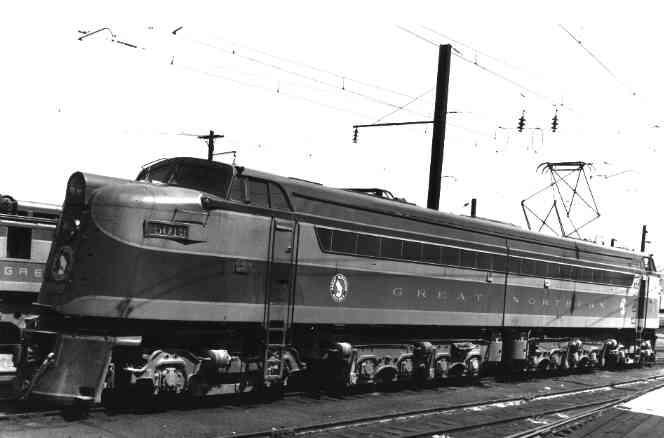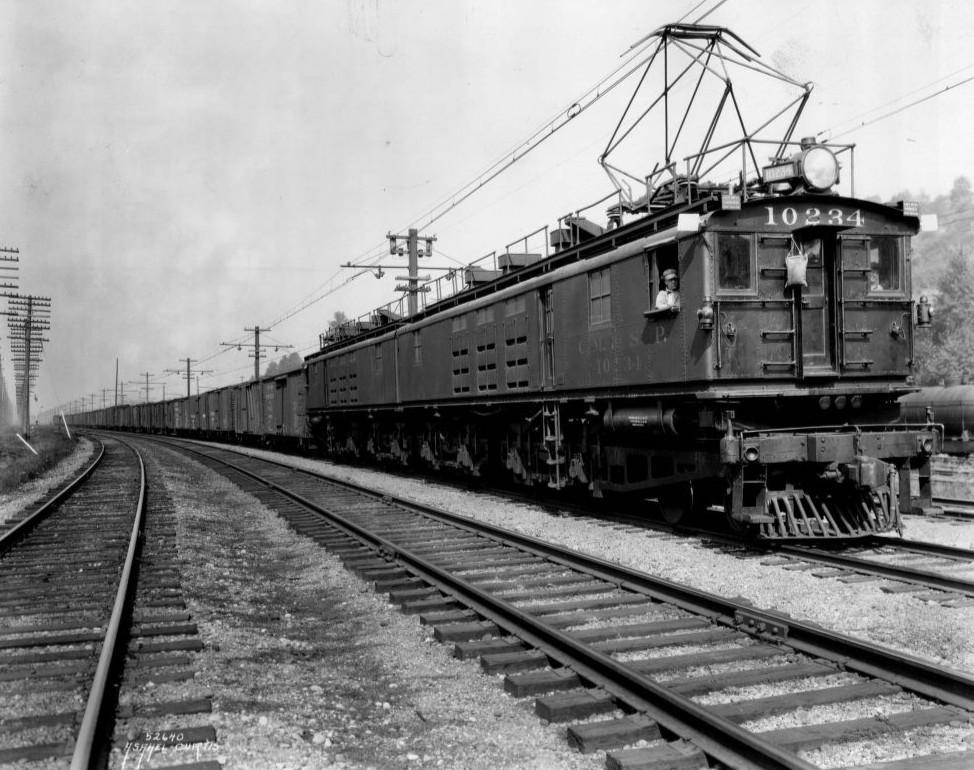The first image is the image on the left, the second image is the image on the right. For the images shown, is this caption "In one vintage image, the engineer is visible through the window of a train heading rightward." true? Answer yes or no. Yes. The first image is the image on the left, the second image is the image on the right. Analyze the images presented: Is the assertion "Each train is run by a cable railway." valid? Answer yes or no. Yes. 